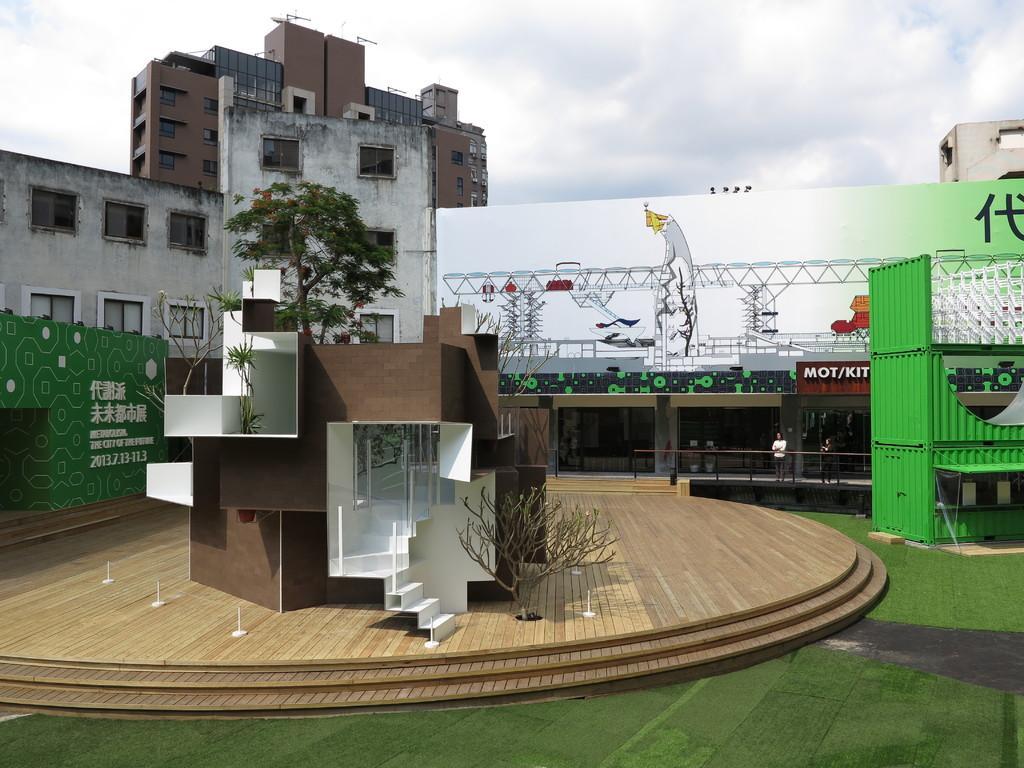How would you summarize this image in a sentence or two? In this image we can see the buildings and a house, there are some persons, trees, windows, staircase, and lighting truss, in the background, we can see the sky with clouds. 